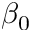Convert formula to latex. <formula><loc_0><loc_0><loc_500><loc_500>\beta _ { 0 }</formula> 